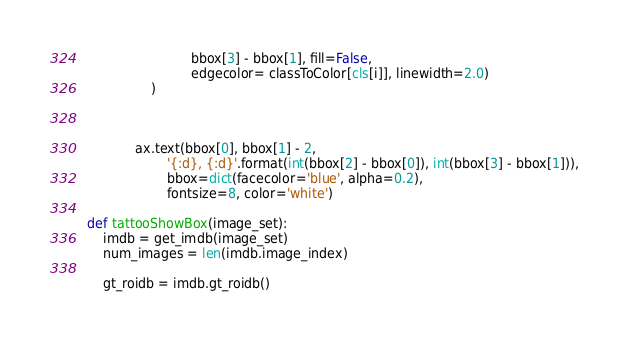<code> <loc_0><loc_0><loc_500><loc_500><_Python_>                          bbox[3] - bbox[1], fill=False,
                          edgecolor= classToColor[cls[i]], linewidth=2.0)
                )



            ax.text(bbox[0], bbox[1] - 2,
                    '{:d}, {:d}'.format(int(bbox[2] - bbox[0]), int(bbox[3] - bbox[1])),
                    bbox=dict(facecolor='blue', alpha=0.2),
                    fontsize=8, color='white')

def tattooShowBox(image_set):
    imdb = get_imdb(image_set)
    num_images = len(imdb.image_index)

    gt_roidb = imdb.gt_roidb()
</code> 